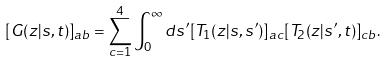<formula> <loc_0><loc_0><loc_500><loc_500>[ G ( z | s , t ) ] _ { a b } = \sum _ { c = 1 } ^ { 4 } \int _ { 0 } ^ { \infty } d s ^ { \prime } [ T _ { 1 } ( z | s , s ^ { \prime } ) ] _ { a c } [ T _ { 2 } ( z | s ^ { \prime } , t ) ] _ { c b } .</formula> 